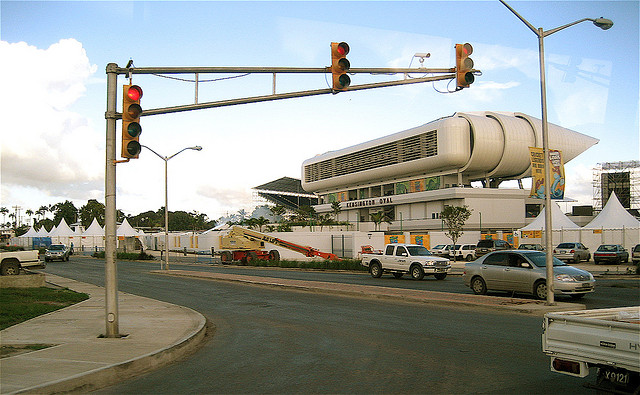<image>Where is this? It is ambiguous and unclear to determine the exact location. However, it could be a city, airport, or fair. Where is this? I don't know where this is. It can be fair, Russia, business, Houston, downtown, New Mexico, city, or airport. 